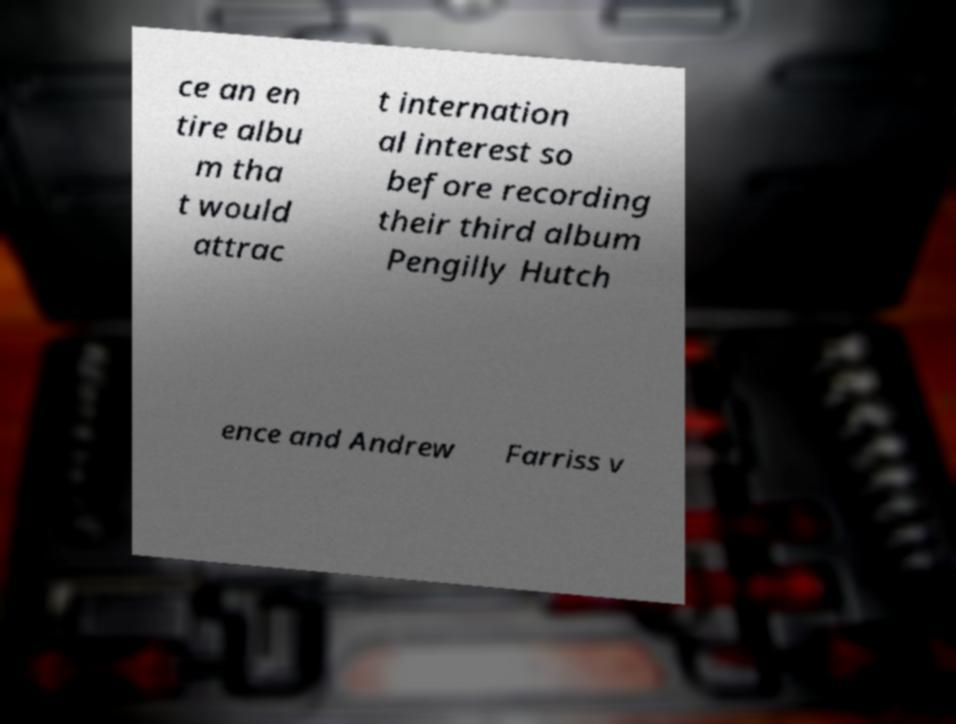Could you extract and type out the text from this image? ce an en tire albu m tha t would attrac t internation al interest so before recording their third album Pengilly Hutch ence and Andrew Farriss v 